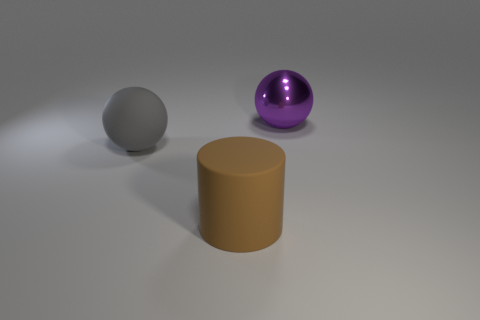Are there any other things that have the same material as the large purple object?
Provide a short and direct response. No. Do the object in front of the gray ball and the large sphere left of the cylinder have the same material?
Your answer should be compact. Yes. There is another big object that is the same shape as the big gray thing; what is it made of?
Ensure brevity in your answer.  Metal. Are the large cylinder and the large gray sphere made of the same material?
Offer a very short reply. Yes. What is the color of the large matte object in front of the ball in front of the large purple shiny sphere?
Make the answer very short. Brown. There is another thing that is the same material as the large brown object; what size is it?
Offer a terse response. Large. What number of purple objects are the same shape as the large gray rubber object?
Offer a very short reply. 1. How many things are big objects that are on the left side of the large purple sphere or objects that are left of the purple thing?
Offer a very short reply. 2. There is a big sphere on the left side of the large brown object; how many big brown cylinders are in front of it?
Give a very brief answer. 1. Do the large thing that is on the right side of the cylinder and the large thing that is in front of the gray matte thing have the same shape?
Offer a very short reply. No. 